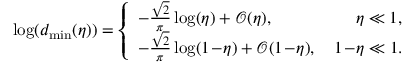<formula> <loc_0><loc_0><loc_500><loc_500>\begin{array} { r } { \log ( d _ { \min } ( \eta ) ) = \left \{ \begin{array} { l l } { - \frac { \sqrt { 2 } } { \pi } \log ( \eta ) + \mathcal { O } ( \eta ) , } & { \quad \, \eta \ll 1 , } \\ { - \frac { \sqrt { 2 } } { \pi } \log ( 1 \, - \, \eta ) + \mathcal { O } ( 1 \, - \, \eta ) , } & { \, 1 \, - \, \eta \ll 1 . } \end{array} } \end{array}</formula> 